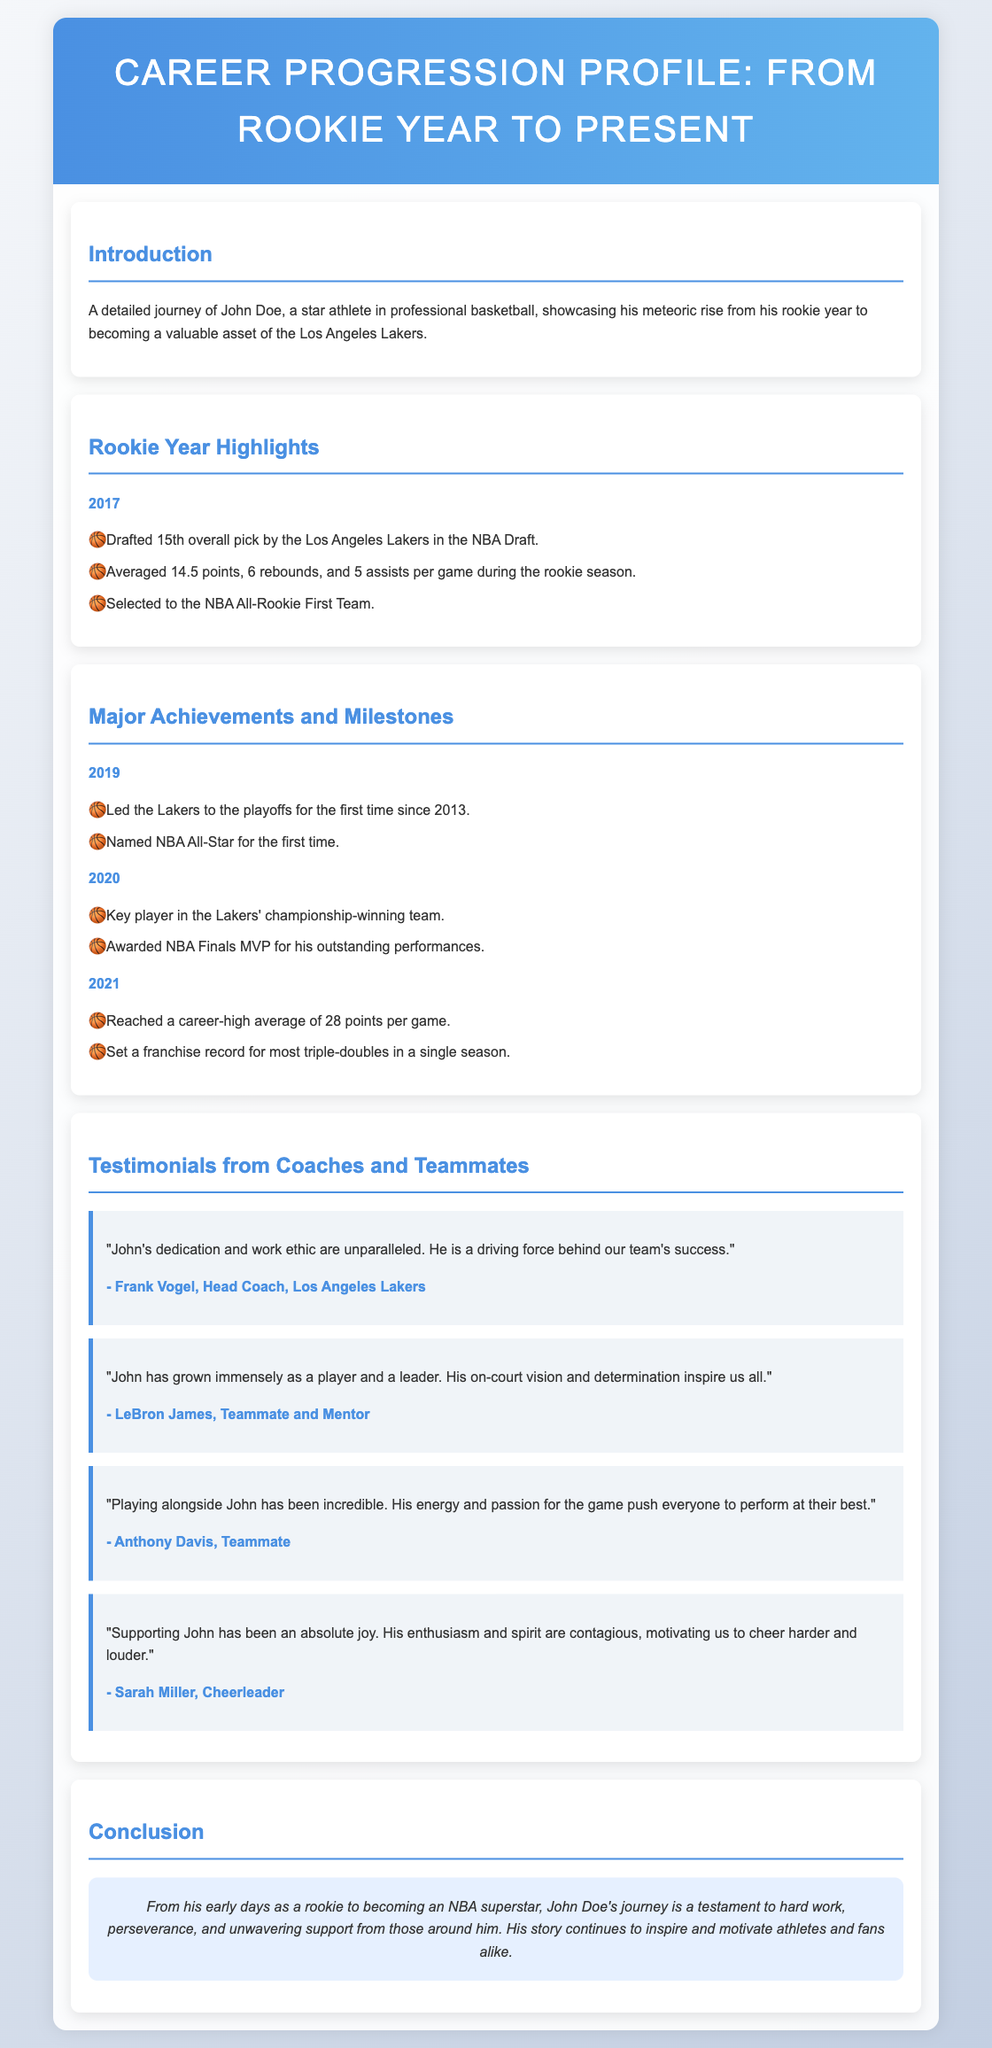What year was John Doe drafted? The document states that John Doe was drafted in 2017.
Answer: 2017 How many points did John average in his rookie season? It is mentioned that he averaged 14.5 points per game during his rookie season.
Answer: 14.5 points Which team did John lead to the playoffs for the first time since 2013? The document indicates that he led the Lakers to the playoffs.
Answer: Lakers Who was awarded NBA Finals MVP in 2020? The document states that John Doe was awarded NBA Finals MVP for his performances in 2020.
Answer: John Doe What franchise record did John set in 2021? The document mentions that he set a franchise record for most triple-doubles in a single season.
Answer: Most triple-doubles What major achievement did John receive in 2019? The document states that John was named NBA All-Star for the first time in 2019.
Answer: NBA All-Star Who is the head coach that provided a testimonial in the document? The document credits Frank Vogel as the head coach who provided a testimonial.
Answer: Frank Vogel Which cheerleader highlighted the joy of supporting John? The document refers to Sarah Miller as the cheerleader who mentioned supporting John.
Answer: Sarah Miller What is the overall theme of John's career progression profile? The conclusion summarizes that it is a testament to hard work, perseverance, and support.
Answer: Hard work, perseverance, and support 